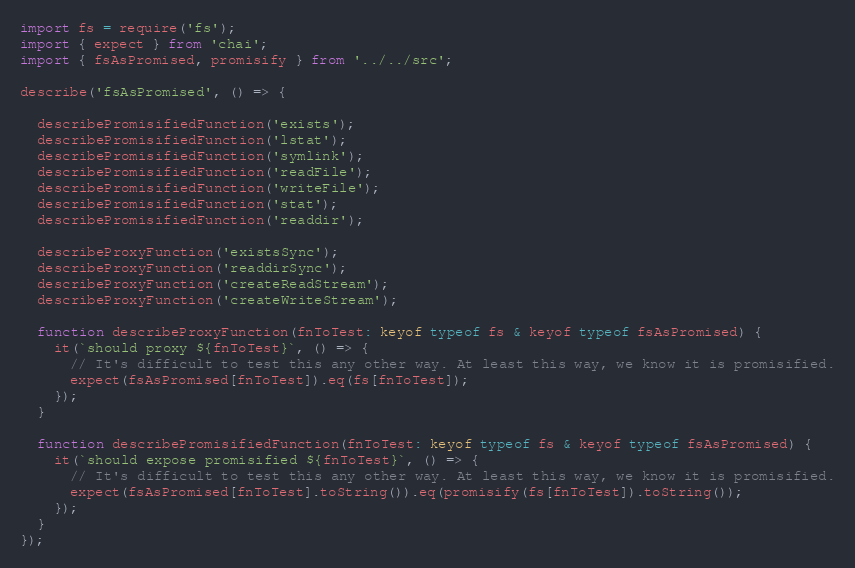<code> <loc_0><loc_0><loc_500><loc_500><_TypeScript_>import fs = require('fs');
import { expect } from 'chai';
import { fsAsPromised, promisify } from '../../src';

describe('fsAsPromised', () => {

  describePromisifiedFunction('exists');
  describePromisifiedFunction('lstat');
  describePromisifiedFunction('symlink');
  describePromisifiedFunction('readFile');
  describePromisifiedFunction('writeFile');
  describePromisifiedFunction('stat');
  describePromisifiedFunction('readdir');

  describeProxyFunction('existsSync');
  describeProxyFunction('readdirSync');
  describeProxyFunction('createReadStream');
  describeProxyFunction('createWriteStream');

  function describeProxyFunction(fnToTest: keyof typeof fs & keyof typeof fsAsPromised) {
    it(`should proxy ${fnToTest}`, () => {
      // It's difficult to test this any other way. At least this way, we know it is promisified.
      expect(fsAsPromised[fnToTest]).eq(fs[fnToTest]);
    });
  }

  function describePromisifiedFunction(fnToTest: keyof typeof fs & keyof typeof fsAsPromised) {
    it(`should expose promisified ${fnToTest}`, () => {
      // It's difficult to test this any other way. At least this way, we know it is promisified.
      expect(fsAsPromised[fnToTest].toString()).eq(promisify(fs[fnToTest]).toString());
    });
  }
});
</code> 